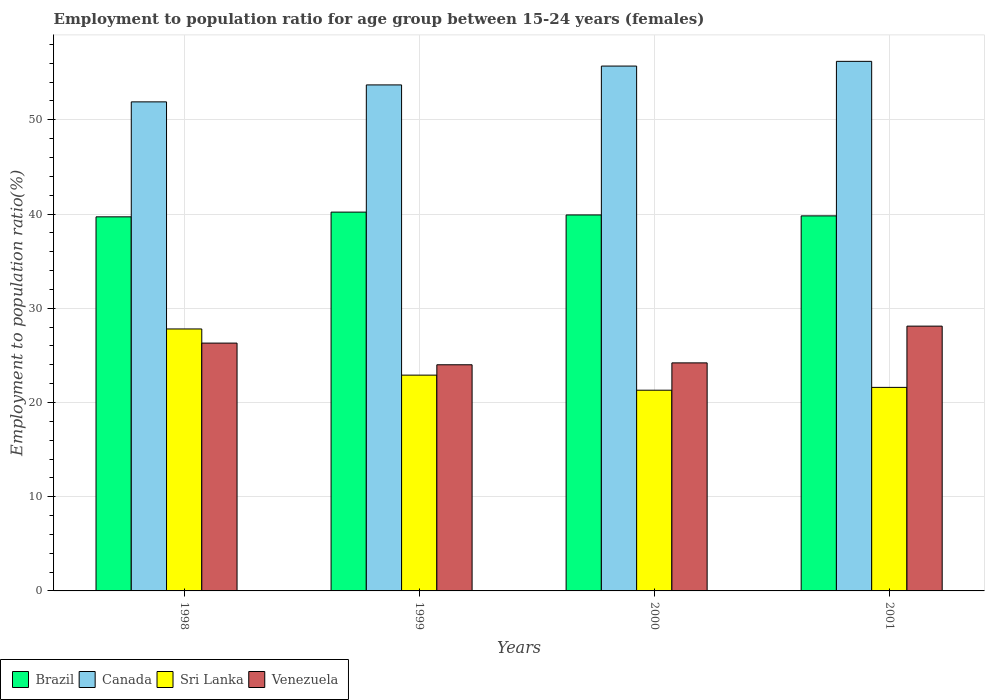How many different coloured bars are there?
Keep it short and to the point. 4. How many groups of bars are there?
Provide a succinct answer. 4. Are the number of bars on each tick of the X-axis equal?
Make the answer very short. Yes. How many bars are there on the 1st tick from the left?
Your response must be concise. 4. How many bars are there on the 2nd tick from the right?
Keep it short and to the point. 4. What is the label of the 2nd group of bars from the left?
Make the answer very short. 1999. In how many cases, is the number of bars for a given year not equal to the number of legend labels?
Ensure brevity in your answer.  0. What is the employment to population ratio in Canada in 1999?
Provide a short and direct response. 53.7. Across all years, what is the maximum employment to population ratio in Sri Lanka?
Make the answer very short. 27.8. Across all years, what is the minimum employment to population ratio in Brazil?
Give a very brief answer. 39.7. What is the total employment to population ratio in Sri Lanka in the graph?
Provide a short and direct response. 93.6. What is the difference between the employment to population ratio in Canada in 1998 and that in 1999?
Ensure brevity in your answer.  -1.8. What is the difference between the employment to population ratio in Brazil in 1998 and the employment to population ratio in Venezuela in 2001?
Your answer should be very brief. 11.6. What is the average employment to population ratio in Sri Lanka per year?
Offer a very short reply. 23.4. In the year 2000, what is the difference between the employment to population ratio in Canada and employment to population ratio in Sri Lanka?
Your response must be concise. 34.4. In how many years, is the employment to population ratio in Canada greater than 22 %?
Offer a very short reply. 4. What is the ratio of the employment to population ratio in Venezuela in 1998 to that in 2000?
Offer a terse response. 1.09. Is the employment to population ratio in Brazil in 1998 less than that in 2000?
Offer a very short reply. Yes. Is the difference between the employment to population ratio in Canada in 1998 and 1999 greater than the difference between the employment to population ratio in Sri Lanka in 1998 and 1999?
Give a very brief answer. No. What is the difference between the highest and the second highest employment to population ratio in Canada?
Make the answer very short. 0.5. What is the difference between the highest and the lowest employment to population ratio in Sri Lanka?
Your answer should be very brief. 6.5. In how many years, is the employment to population ratio in Canada greater than the average employment to population ratio in Canada taken over all years?
Provide a short and direct response. 2. Is the sum of the employment to population ratio in Canada in 1998 and 1999 greater than the maximum employment to population ratio in Venezuela across all years?
Your response must be concise. Yes. Is it the case that in every year, the sum of the employment to population ratio in Brazil and employment to population ratio in Canada is greater than the sum of employment to population ratio in Sri Lanka and employment to population ratio in Venezuela?
Ensure brevity in your answer.  Yes. What does the 1st bar from the left in 2000 represents?
Offer a very short reply. Brazil. What does the 3rd bar from the right in 1998 represents?
Your answer should be very brief. Canada. Is it the case that in every year, the sum of the employment to population ratio in Sri Lanka and employment to population ratio in Canada is greater than the employment to population ratio in Venezuela?
Give a very brief answer. Yes. How many bars are there?
Keep it short and to the point. 16. Are the values on the major ticks of Y-axis written in scientific E-notation?
Your response must be concise. No. How many legend labels are there?
Ensure brevity in your answer.  4. What is the title of the graph?
Your response must be concise. Employment to population ratio for age group between 15-24 years (females). What is the label or title of the Y-axis?
Provide a succinct answer. Employment to population ratio(%). What is the Employment to population ratio(%) of Brazil in 1998?
Your answer should be compact. 39.7. What is the Employment to population ratio(%) in Canada in 1998?
Ensure brevity in your answer.  51.9. What is the Employment to population ratio(%) of Sri Lanka in 1998?
Make the answer very short. 27.8. What is the Employment to population ratio(%) in Venezuela in 1998?
Provide a succinct answer. 26.3. What is the Employment to population ratio(%) of Brazil in 1999?
Provide a succinct answer. 40.2. What is the Employment to population ratio(%) of Canada in 1999?
Your response must be concise. 53.7. What is the Employment to population ratio(%) of Sri Lanka in 1999?
Offer a terse response. 22.9. What is the Employment to population ratio(%) in Venezuela in 1999?
Offer a terse response. 24. What is the Employment to population ratio(%) of Brazil in 2000?
Provide a short and direct response. 39.9. What is the Employment to population ratio(%) of Canada in 2000?
Offer a very short reply. 55.7. What is the Employment to population ratio(%) in Sri Lanka in 2000?
Offer a very short reply. 21.3. What is the Employment to population ratio(%) in Venezuela in 2000?
Ensure brevity in your answer.  24.2. What is the Employment to population ratio(%) in Brazil in 2001?
Offer a terse response. 39.8. What is the Employment to population ratio(%) of Canada in 2001?
Ensure brevity in your answer.  56.2. What is the Employment to population ratio(%) of Sri Lanka in 2001?
Your answer should be very brief. 21.6. What is the Employment to population ratio(%) in Venezuela in 2001?
Offer a terse response. 28.1. Across all years, what is the maximum Employment to population ratio(%) of Brazil?
Provide a succinct answer. 40.2. Across all years, what is the maximum Employment to population ratio(%) of Canada?
Offer a very short reply. 56.2. Across all years, what is the maximum Employment to population ratio(%) in Sri Lanka?
Your response must be concise. 27.8. Across all years, what is the maximum Employment to population ratio(%) of Venezuela?
Offer a terse response. 28.1. Across all years, what is the minimum Employment to population ratio(%) of Brazil?
Make the answer very short. 39.7. Across all years, what is the minimum Employment to population ratio(%) in Canada?
Your answer should be compact. 51.9. Across all years, what is the minimum Employment to population ratio(%) of Sri Lanka?
Provide a short and direct response. 21.3. Across all years, what is the minimum Employment to population ratio(%) in Venezuela?
Give a very brief answer. 24. What is the total Employment to population ratio(%) in Brazil in the graph?
Keep it short and to the point. 159.6. What is the total Employment to population ratio(%) of Canada in the graph?
Provide a succinct answer. 217.5. What is the total Employment to population ratio(%) of Sri Lanka in the graph?
Your answer should be very brief. 93.6. What is the total Employment to population ratio(%) in Venezuela in the graph?
Ensure brevity in your answer.  102.6. What is the difference between the Employment to population ratio(%) in Canada in 1998 and that in 1999?
Make the answer very short. -1.8. What is the difference between the Employment to population ratio(%) of Brazil in 1998 and that in 2000?
Your answer should be compact. -0.2. What is the difference between the Employment to population ratio(%) of Canada in 1998 and that in 2001?
Your answer should be very brief. -4.3. What is the difference between the Employment to population ratio(%) of Sri Lanka in 1998 and that in 2001?
Your response must be concise. 6.2. What is the difference between the Employment to population ratio(%) of Venezuela in 1998 and that in 2001?
Keep it short and to the point. -1.8. What is the difference between the Employment to population ratio(%) in Canada in 1999 and that in 2000?
Your response must be concise. -2. What is the difference between the Employment to population ratio(%) in Sri Lanka in 1999 and that in 2000?
Provide a succinct answer. 1.6. What is the difference between the Employment to population ratio(%) in Venezuela in 1999 and that in 2000?
Give a very brief answer. -0.2. What is the difference between the Employment to population ratio(%) of Brazil in 1999 and that in 2001?
Offer a terse response. 0.4. What is the difference between the Employment to population ratio(%) in Sri Lanka in 1999 and that in 2001?
Your answer should be compact. 1.3. What is the difference between the Employment to population ratio(%) in Brazil in 2000 and that in 2001?
Your answer should be compact. 0.1. What is the difference between the Employment to population ratio(%) in Brazil in 1998 and the Employment to population ratio(%) in Canada in 1999?
Your answer should be compact. -14. What is the difference between the Employment to population ratio(%) of Canada in 1998 and the Employment to population ratio(%) of Venezuela in 1999?
Provide a succinct answer. 27.9. What is the difference between the Employment to population ratio(%) of Canada in 1998 and the Employment to population ratio(%) of Sri Lanka in 2000?
Provide a short and direct response. 30.6. What is the difference between the Employment to population ratio(%) of Canada in 1998 and the Employment to population ratio(%) of Venezuela in 2000?
Your answer should be compact. 27.7. What is the difference between the Employment to population ratio(%) in Sri Lanka in 1998 and the Employment to population ratio(%) in Venezuela in 2000?
Keep it short and to the point. 3.6. What is the difference between the Employment to population ratio(%) in Brazil in 1998 and the Employment to population ratio(%) in Canada in 2001?
Your answer should be very brief. -16.5. What is the difference between the Employment to population ratio(%) in Brazil in 1998 and the Employment to population ratio(%) in Venezuela in 2001?
Offer a terse response. 11.6. What is the difference between the Employment to population ratio(%) of Canada in 1998 and the Employment to population ratio(%) of Sri Lanka in 2001?
Provide a short and direct response. 30.3. What is the difference between the Employment to population ratio(%) of Canada in 1998 and the Employment to population ratio(%) of Venezuela in 2001?
Ensure brevity in your answer.  23.8. What is the difference between the Employment to population ratio(%) in Sri Lanka in 1998 and the Employment to population ratio(%) in Venezuela in 2001?
Provide a short and direct response. -0.3. What is the difference between the Employment to population ratio(%) in Brazil in 1999 and the Employment to population ratio(%) in Canada in 2000?
Give a very brief answer. -15.5. What is the difference between the Employment to population ratio(%) in Brazil in 1999 and the Employment to population ratio(%) in Sri Lanka in 2000?
Your response must be concise. 18.9. What is the difference between the Employment to population ratio(%) of Brazil in 1999 and the Employment to population ratio(%) of Venezuela in 2000?
Offer a terse response. 16. What is the difference between the Employment to population ratio(%) in Canada in 1999 and the Employment to population ratio(%) in Sri Lanka in 2000?
Your answer should be very brief. 32.4. What is the difference between the Employment to population ratio(%) in Canada in 1999 and the Employment to population ratio(%) in Venezuela in 2000?
Your answer should be very brief. 29.5. What is the difference between the Employment to population ratio(%) of Sri Lanka in 1999 and the Employment to population ratio(%) of Venezuela in 2000?
Give a very brief answer. -1.3. What is the difference between the Employment to population ratio(%) of Brazil in 1999 and the Employment to population ratio(%) of Sri Lanka in 2001?
Your response must be concise. 18.6. What is the difference between the Employment to population ratio(%) in Brazil in 1999 and the Employment to population ratio(%) in Venezuela in 2001?
Provide a short and direct response. 12.1. What is the difference between the Employment to population ratio(%) of Canada in 1999 and the Employment to population ratio(%) of Sri Lanka in 2001?
Offer a very short reply. 32.1. What is the difference between the Employment to population ratio(%) of Canada in 1999 and the Employment to population ratio(%) of Venezuela in 2001?
Your answer should be very brief. 25.6. What is the difference between the Employment to population ratio(%) of Brazil in 2000 and the Employment to population ratio(%) of Canada in 2001?
Your response must be concise. -16.3. What is the difference between the Employment to population ratio(%) in Brazil in 2000 and the Employment to population ratio(%) in Sri Lanka in 2001?
Offer a very short reply. 18.3. What is the difference between the Employment to population ratio(%) in Canada in 2000 and the Employment to population ratio(%) in Sri Lanka in 2001?
Offer a very short reply. 34.1. What is the difference between the Employment to population ratio(%) in Canada in 2000 and the Employment to population ratio(%) in Venezuela in 2001?
Give a very brief answer. 27.6. What is the average Employment to population ratio(%) of Brazil per year?
Give a very brief answer. 39.9. What is the average Employment to population ratio(%) in Canada per year?
Your answer should be compact. 54.38. What is the average Employment to population ratio(%) in Sri Lanka per year?
Make the answer very short. 23.4. What is the average Employment to population ratio(%) in Venezuela per year?
Offer a very short reply. 25.65. In the year 1998, what is the difference between the Employment to population ratio(%) of Brazil and Employment to population ratio(%) of Sri Lanka?
Offer a very short reply. 11.9. In the year 1998, what is the difference between the Employment to population ratio(%) of Brazil and Employment to population ratio(%) of Venezuela?
Your answer should be compact. 13.4. In the year 1998, what is the difference between the Employment to population ratio(%) in Canada and Employment to population ratio(%) in Sri Lanka?
Your answer should be compact. 24.1. In the year 1998, what is the difference between the Employment to population ratio(%) of Canada and Employment to population ratio(%) of Venezuela?
Offer a terse response. 25.6. In the year 1999, what is the difference between the Employment to population ratio(%) in Brazil and Employment to population ratio(%) in Canada?
Provide a short and direct response. -13.5. In the year 1999, what is the difference between the Employment to population ratio(%) in Brazil and Employment to population ratio(%) in Venezuela?
Offer a terse response. 16.2. In the year 1999, what is the difference between the Employment to population ratio(%) of Canada and Employment to population ratio(%) of Sri Lanka?
Provide a succinct answer. 30.8. In the year 1999, what is the difference between the Employment to population ratio(%) of Canada and Employment to population ratio(%) of Venezuela?
Your answer should be very brief. 29.7. In the year 2000, what is the difference between the Employment to population ratio(%) in Brazil and Employment to population ratio(%) in Canada?
Offer a terse response. -15.8. In the year 2000, what is the difference between the Employment to population ratio(%) of Brazil and Employment to population ratio(%) of Sri Lanka?
Give a very brief answer. 18.6. In the year 2000, what is the difference between the Employment to population ratio(%) of Brazil and Employment to population ratio(%) of Venezuela?
Your response must be concise. 15.7. In the year 2000, what is the difference between the Employment to population ratio(%) of Canada and Employment to population ratio(%) of Sri Lanka?
Offer a terse response. 34.4. In the year 2000, what is the difference between the Employment to population ratio(%) in Canada and Employment to population ratio(%) in Venezuela?
Your answer should be compact. 31.5. In the year 2001, what is the difference between the Employment to population ratio(%) of Brazil and Employment to population ratio(%) of Canada?
Ensure brevity in your answer.  -16.4. In the year 2001, what is the difference between the Employment to population ratio(%) of Canada and Employment to population ratio(%) of Sri Lanka?
Ensure brevity in your answer.  34.6. In the year 2001, what is the difference between the Employment to population ratio(%) in Canada and Employment to population ratio(%) in Venezuela?
Provide a short and direct response. 28.1. What is the ratio of the Employment to population ratio(%) of Brazil in 1998 to that in 1999?
Make the answer very short. 0.99. What is the ratio of the Employment to population ratio(%) in Canada in 1998 to that in 1999?
Your answer should be compact. 0.97. What is the ratio of the Employment to population ratio(%) of Sri Lanka in 1998 to that in 1999?
Offer a terse response. 1.21. What is the ratio of the Employment to population ratio(%) in Venezuela in 1998 to that in 1999?
Give a very brief answer. 1.1. What is the ratio of the Employment to population ratio(%) of Brazil in 1998 to that in 2000?
Offer a terse response. 0.99. What is the ratio of the Employment to population ratio(%) in Canada in 1998 to that in 2000?
Provide a succinct answer. 0.93. What is the ratio of the Employment to population ratio(%) in Sri Lanka in 1998 to that in 2000?
Keep it short and to the point. 1.31. What is the ratio of the Employment to population ratio(%) of Venezuela in 1998 to that in 2000?
Your answer should be compact. 1.09. What is the ratio of the Employment to population ratio(%) of Canada in 1998 to that in 2001?
Your answer should be compact. 0.92. What is the ratio of the Employment to population ratio(%) of Sri Lanka in 1998 to that in 2001?
Offer a very short reply. 1.29. What is the ratio of the Employment to population ratio(%) in Venezuela in 1998 to that in 2001?
Offer a terse response. 0.94. What is the ratio of the Employment to population ratio(%) in Brazil in 1999 to that in 2000?
Your answer should be very brief. 1.01. What is the ratio of the Employment to population ratio(%) of Canada in 1999 to that in 2000?
Provide a succinct answer. 0.96. What is the ratio of the Employment to population ratio(%) in Sri Lanka in 1999 to that in 2000?
Ensure brevity in your answer.  1.08. What is the ratio of the Employment to population ratio(%) in Canada in 1999 to that in 2001?
Your answer should be very brief. 0.96. What is the ratio of the Employment to population ratio(%) of Sri Lanka in 1999 to that in 2001?
Give a very brief answer. 1.06. What is the ratio of the Employment to population ratio(%) of Venezuela in 1999 to that in 2001?
Offer a terse response. 0.85. What is the ratio of the Employment to population ratio(%) in Sri Lanka in 2000 to that in 2001?
Provide a short and direct response. 0.99. What is the ratio of the Employment to population ratio(%) of Venezuela in 2000 to that in 2001?
Your answer should be compact. 0.86. What is the difference between the highest and the second highest Employment to population ratio(%) of Brazil?
Ensure brevity in your answer.  0.3. What is the difference between the highest and the second highest Employment to population ratio(%) of Canada?
Your response must be concise. 0.5. What is the difference between the highest and the second highest Employment to population ratio(%) in Venezuela?
Offer a very short reply. 1.8. What is the difference between the highest and the lowest Employment to population ratio(%) of Sri Lanka?
Your answer should be compact. 6.5. 